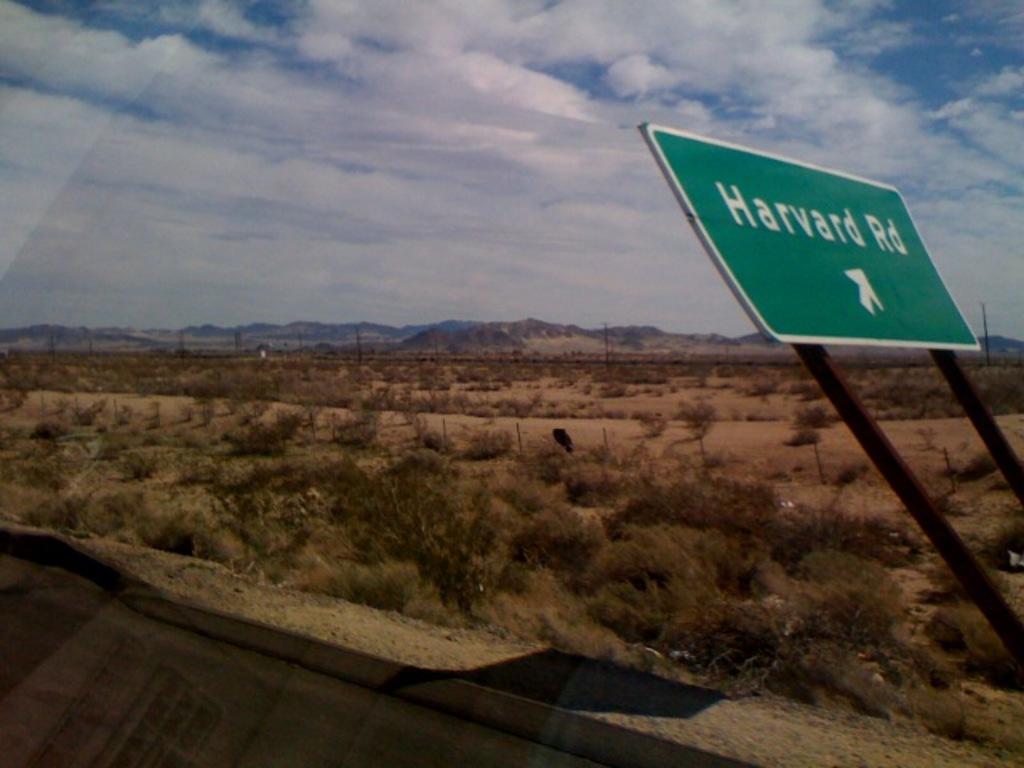What is the road name?
Offer a terse response. Harvard rd. 